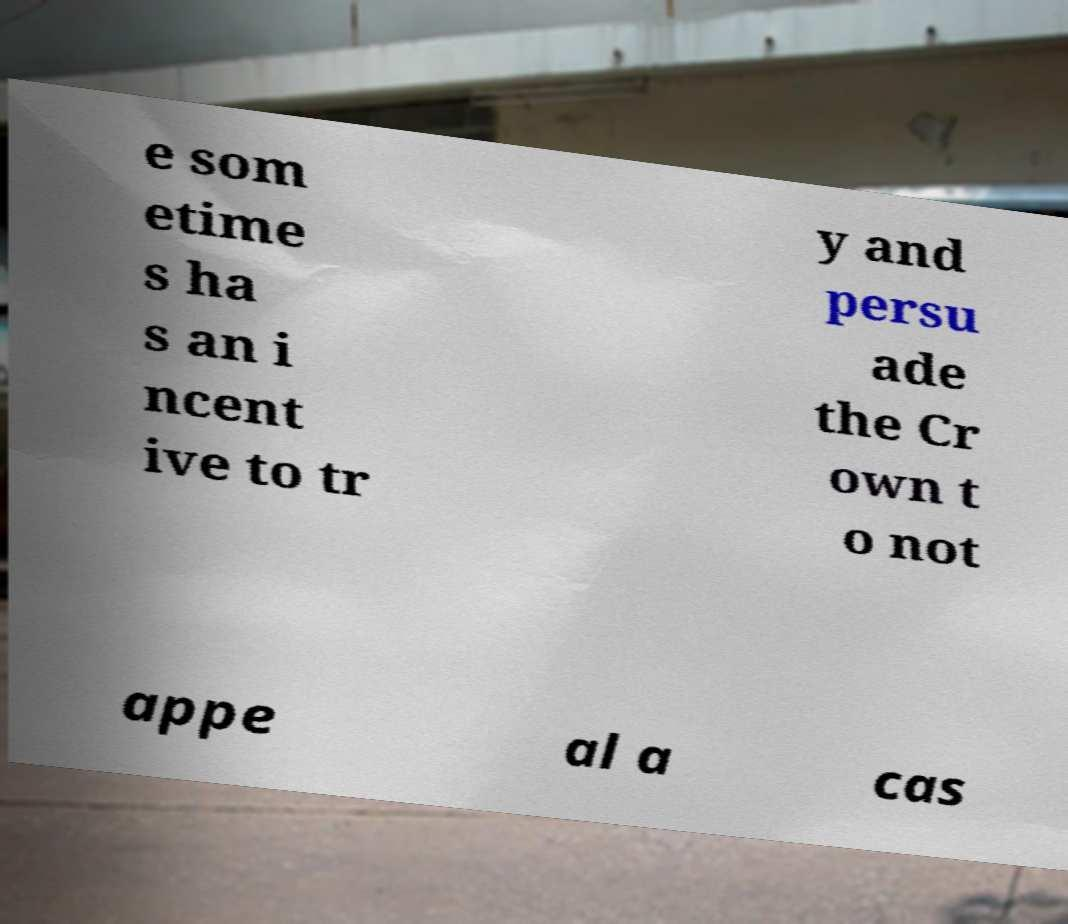Can you read and provide the text displayed in the image?This photo seems to have some interesting text. Can you extract and type it out for me? e som etime s ha s an i ncent ive to tr y and persu ade the Cr own t o not appe al a cas 